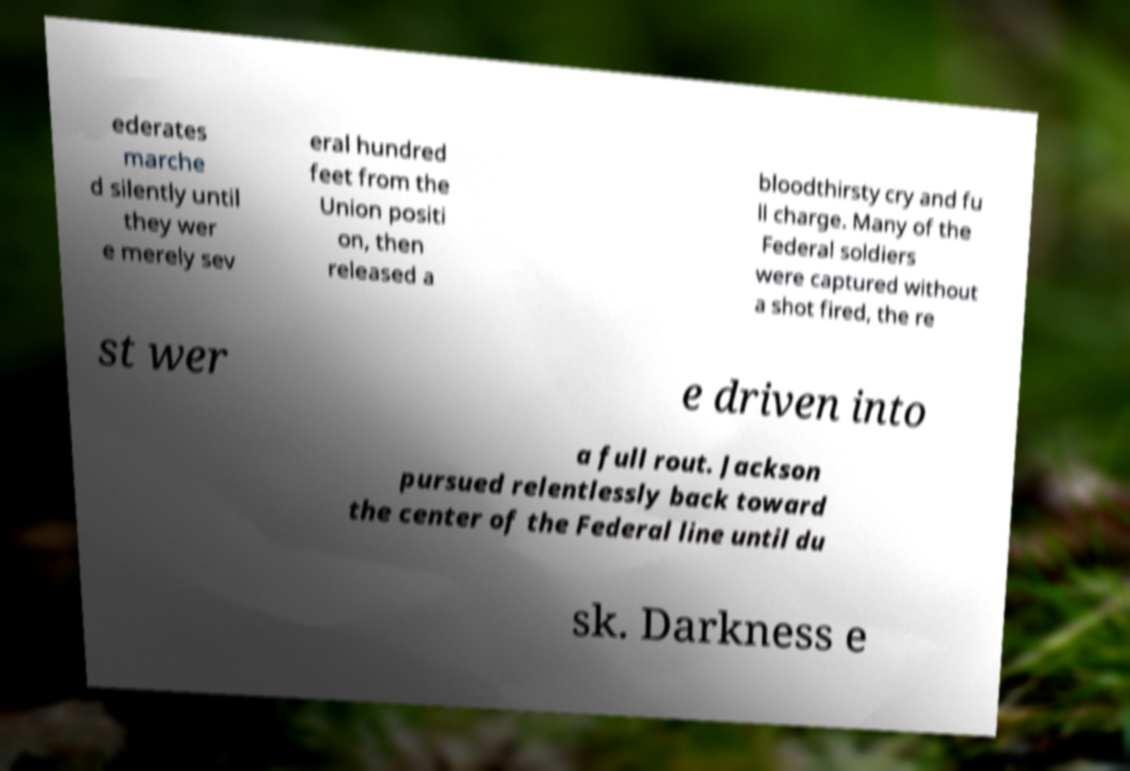Can you accurately transcribe the text from the provided image for me? ederates marche d silently until they wer e merely sev eral hundred feet from the Union positi on, then released a bloodthirsty cry and fu ll charge. Many of the Federal soldiers were captured without a shot fired, the re st wer e driven into a full rout. Jackson pursued relentlessly back toward the center of the Federal line until du sk. Darkness e 